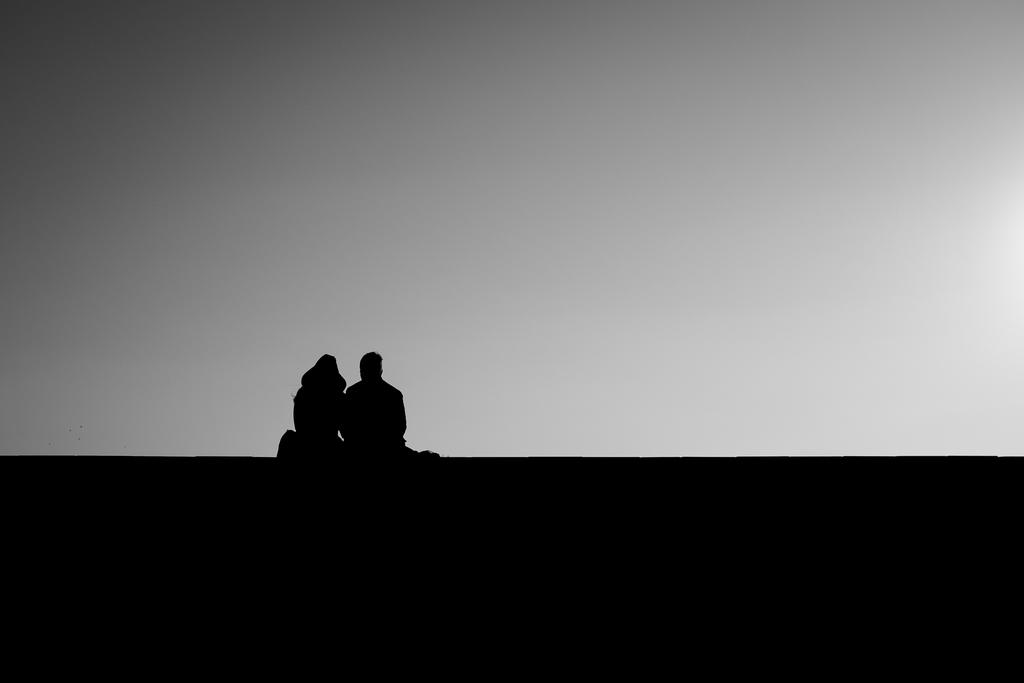What is happening in the image? There are people (a man and a woman) sitting in the image. What can be seen in the background of the image? There is a cloudy sky in the background of the image. What type of star can be seen on the woman's shirt in the image? There is no star visible on the woman's shirt in the image. What kind of paste is being used by the man in the image? There is no paste or any indication of its use in the image. 